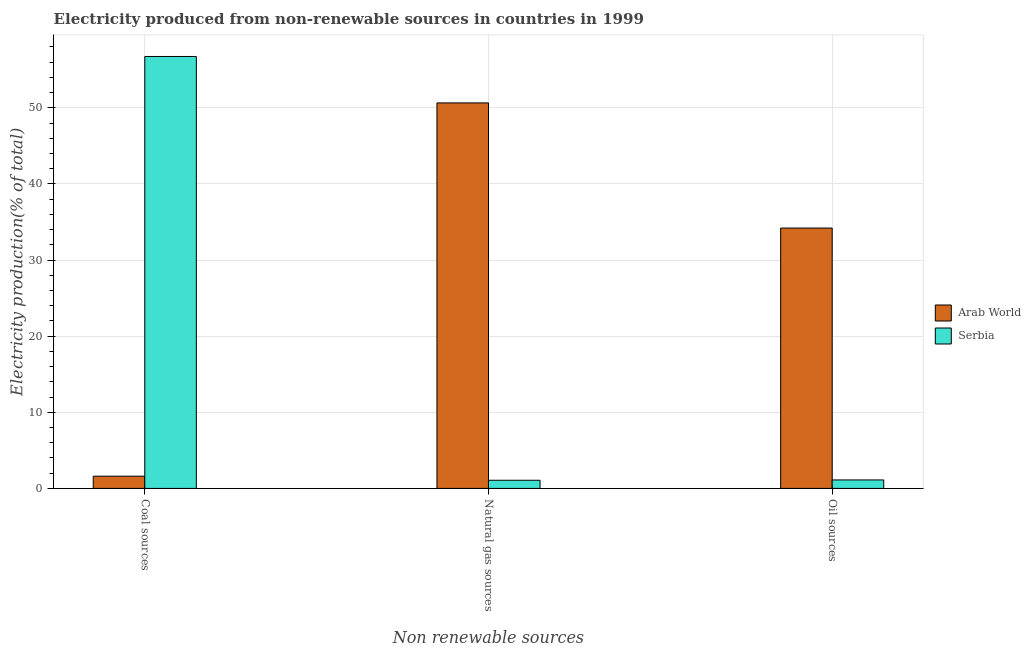How many different coloured bars are there?
Make the answer very short. 2. Are the number of bars on each tick of the X-axis equal?
Your response must be concise. Yes. How many bars are there on the 2nd tick from the left?
Give a very brief answer. 2. How many bars are there on the 3rd tick from the right?
Your response must be concise. 2. What is the label of the 3rd group of bars from the left?
Provide a succinct answer. Oil sources. What is the percentage of electricity produced by natural gas in Serbia?
Offer a terse response. 1.07. Across all countries, what is the maximum percentage of electricity produced by natural gas?
Provide a succinct answer. 50.65. Across all countries, what is the minimum percentage of electricity produced by natural gas?
Your answer should be compact. 1.07. In which country was the percentage of electricity produced by oil sources maximum?
Keep it short and to the point. Arab World. In which country was the percentage of electricity produced by coal minimum?
Your answer should be very brief. Arab World. What is the total percentage of electricity produced by oil sources in the graph?
Your answer should be very brief. 35.32. What is the difference between the percentage of electricity produced by oil sources in Arab World and that in Serbia?
Your response must be concise. 33.09. What is the difference between the percentage of electricity produced by natural gas in Arab World and the percentage of electricity produced by coal in Serbia?
Make the answer very short. -6.1. What is the average percentage of electricity produced by coal per country?
Keep it short and to the point. 29.18. What is the difference between the percentage of electricity produced by natural gas and percentage of electricity produced by oil sources in Arab World?
Ensure brevity in your answer.  16.44. In how many countries, is the percentage of electricity produced by natural gas greater than 32 %?
Ensure brevity in your answer.  1. What is the ratio of the percentage of electricity produced by coal in Arab World to that in Serbia?
Your response must be concise. 0.03. What is the difference between the highest and the second highest percentage of electricity produced by coal?
Offer a very short reply. 55.14. What is the difference between the highest and the lowest percentage of electricity produced by coal?
Your response must be concise. 55.14. In how many countries, is the percentage of electricity produced by coal greater than the average percentage of electricity produced by coal taken over all countries?
Keep it short and to the point. 1. What does the 1st bar from the left in Coal sources represents?
Offer a very short reply. Arab World. What does the 1st bar from the right in Coal sources represents?
Offer a terse response. Serbia. Is it the case that in every country, the sum of the percentage of electricity produced by coal and percentage of electricity produced by natural gas is greater than the percentage of electricity produced by oil sources?
Provide a short and direct response. Yes. How many bars are there?
Offer a terse response. 6. How many countries are there in the graph?
Provide a succinct answer. 2. Does the graph contain grids?
Offer a very short reply. Yes. What is the title of the graph?
Give a very brief answer. Electricity produced from non-renewable sources in countries in 1999. What is the label or title of the X-axis?
Make the answer very short. Non renewable sources. What is the Electricity production(% of total) of Arab World in Coal sources?
Offer a very short reply. 1.61. What is the Electricity production(% of total) in Serbia in Coal sources?
Keep it short and to the point. 56.75. What is the Electricity production(% of total) of Arab World in Natural gas sources?
Offer a terse response. 50.65. What is the Electricity production(% of total) of Serbia in Natural gas sources?
Your answer should be very brief. 1.07. What is the Electricity production(% of total) in Arab World in Oil sources?
Offer a terse response. 34.21. What is the Electricity production(% of total) in Serbia in Oil sources?
Provide a succinct answer. 1.11. Across all Non renewable sources, what is the maximum Electricity production(% of total) in Arab World?
Your answer should be compact. 50.65. Across all Non renewable sources, what is the maximum Electricity production(% of total) in Serbia?
Give a very brief answer. 56.75. Across all Non renewable sources, what is the minimum Electricity production(% of total) in Arab World?
Your answer should be very brief. 1.61. Across all Non renewable sources, what is the minimum Electricity production(% of total) in Serbia?
Keep it short and to the point. 1.07. What is the total Electricity production(% of total) of Arab World in the graph?
Ensure brevity in your answer.  86.46. What is the total Electricity production(% of total) of Serbia in the graph?
Provide a succinct answer. 58.93. What is the difference between the Electricity production(% of total) of Arab World in Coal sources and that in Natural gas sources?
Your response must be concise. -49.04. What is the difference between the Electricity production(% of total) of Serbia in Coal sources and that in Natural gas sources?
Provide a succinct answer. 55.68. What is the difference between the Electricity production(% of total) in Arab World in Coal sources and that in Oil sources?
Offer a terse response. -32.6. What is the difference between the Electricity production(% of total) of Serbia in Coal sources and that in Oil sources?
Keep it short and to the point. 55.64. What is the difference between the Electricity production(% of total) in Arab World in Natural gas sources and that in Oil sources?
Ensure brevity in your answer.  16.44. What is the difference between the Electricity production(% of total) of Serbia in Natural gas sources and that in Oil sources?
Your response must be concise. -0.04. What is the difference between the Electricity production(% of total) of Arab World in Coal sources and the Electricity production(% of total) of Serbia in Natural gas sources?
Make the answer very short. 0.54. What is the difference between the Electricity production(% of total) of Arab World in Coal sources and the Electricity production(% of total) of Serbia in Oil sources?
Offer a terse response. 0.49. What is the difference between the Electricity production(% of total) of Arab World in Natural gas sources and the Electricity production(% of total) of Serbia in Oil sources?
Ensure brevity in your answer.  49.53. What is the average Electricity production(% of total) in Arab World per Non renewable sources?
Provide a succinct answer. 28.82. What is the average Electricity production(% of total) in Serbia per Non renewable sources?
Keep it short and to the point. 19.64. What is the difference between the Electricity production(% of total) of Arab World and Electricity production(% of total) of Serbia in Coal sources?
Your answer should be very brief. -55.14. What is the difference between the Electricity production(% of total) in Arab World and Electricity production(% of total) in Serbia in Natural gas sources?
Your response must be concise. 49.58. What is the difference between the Electricity production(% of total) in Arab World and Electricity production(% of total) in Serbia in Oil sources?
Offer a terse response. 33.09. What is the ratio of the Electricity production(% of total) in Arab World in Coal sources to that in Natural gas sources?
Your answer should be compact. 0.03. What is the ratio of the Electricity production(% of total) of Serbia in Coal sources to that in Natural gas sources?
Give a very brief answer. 52.96. What is the ratio of the Electricity production(% of total) in Arab World in Coal sources to that in Oil sources?
Offer a terse response. 0.05. What is the ratio of the Electricity production(% of total) in Serbia in Coal sources to that in Oil sources?
Your answer should be very brief. 50.97. What is the ratio of the Electricity production(% of total) in Arab World in Natural gas sources to that in Oil sources?
Your response must be concise. 1.48. What is the ratio of the Electricity production(% of total) of Serbia in Natural gas sources to that in Oil sources?
Offer a very short reply. 0.96. What is the difference between the highest and the second highest Electricity production(% of total) in Arab World?
Your response must be concise. 16.44. What is the difference between the highest and the second highest Electricity production(% of total) of Serbia?
Your answer should be very brief. 55.64. What is the difference between the highest and the lowest Electricity production(% of total) of Arab World?
Offer a terse response. 49.04. What is the difference between the highest and the lowest Electricity production(% of total) of Serbia?
Ensure brevity in your answer.  55.68. 